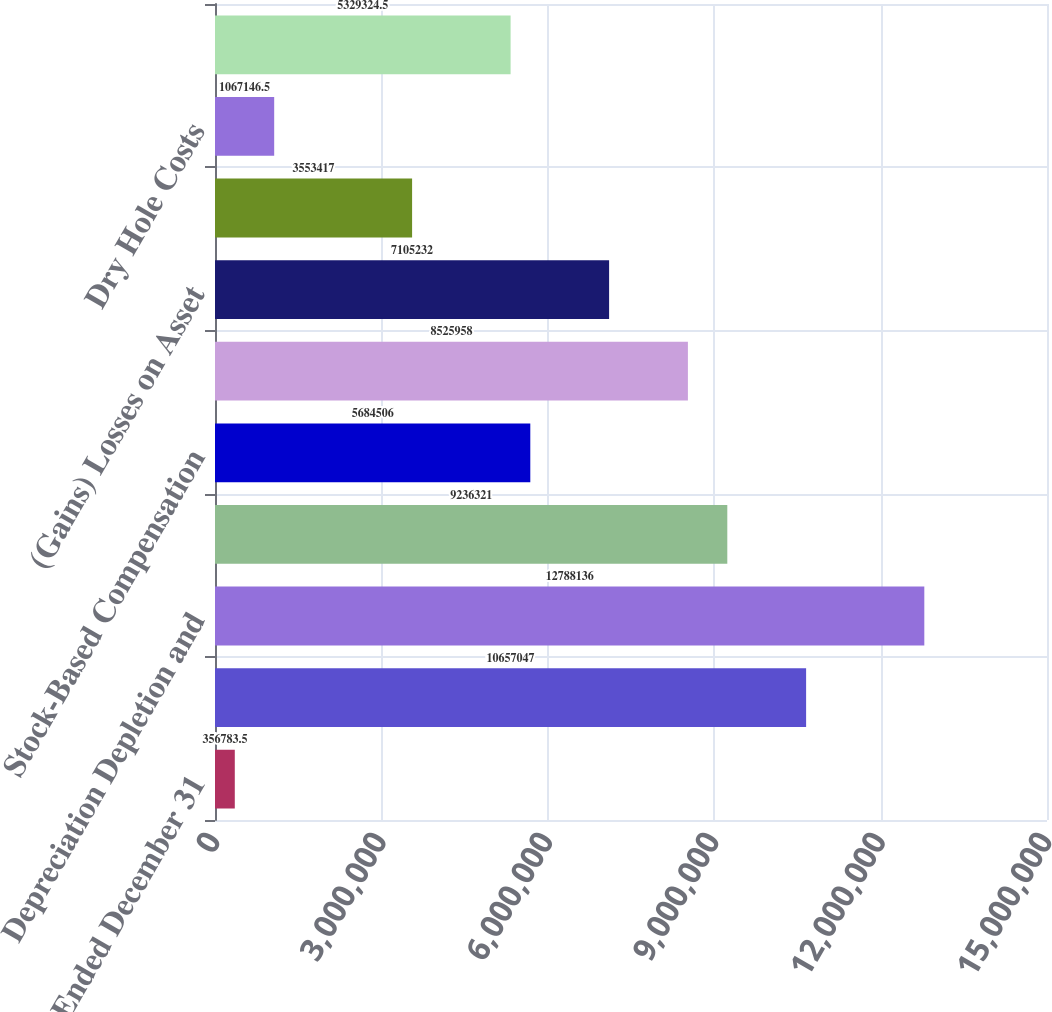Convert chart. <chart><loc_0><loc_0><loc_500><loc_500><bar_chart><fcel>Year Ended December 31<fcel>Net Income (Loss)<fcel>Depreciation Depletion and<fcel>Impairments<fcel>Stock-Based Compensation<fcel>Deferred Income Taxes<fcel>(Gains) Losses on Asset<fcel>Other Net<fcel>Dry Hole Costs<fcel>Total Losses (Gains)<nl><fcel>356784<fcel>1.0657e+07<fcel>1.27881e+07<fcel>9.23632e+06<fcel>5.68451e+06<fcel>8.52596e+06<fcel>7.10523e+06<fcel>3.55342e+06<fcel>1.06715e+06<fcel>5.32932e+06<nl></chart> 